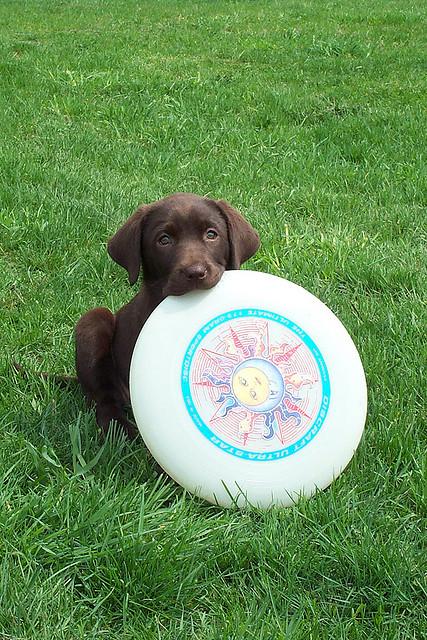What color is the sun face on the Frisbee?
Quick response, please. Yellow. Is the Frisbee white?
Short answer required. Yes. Is the dog full grown?
Be succinct. No. 